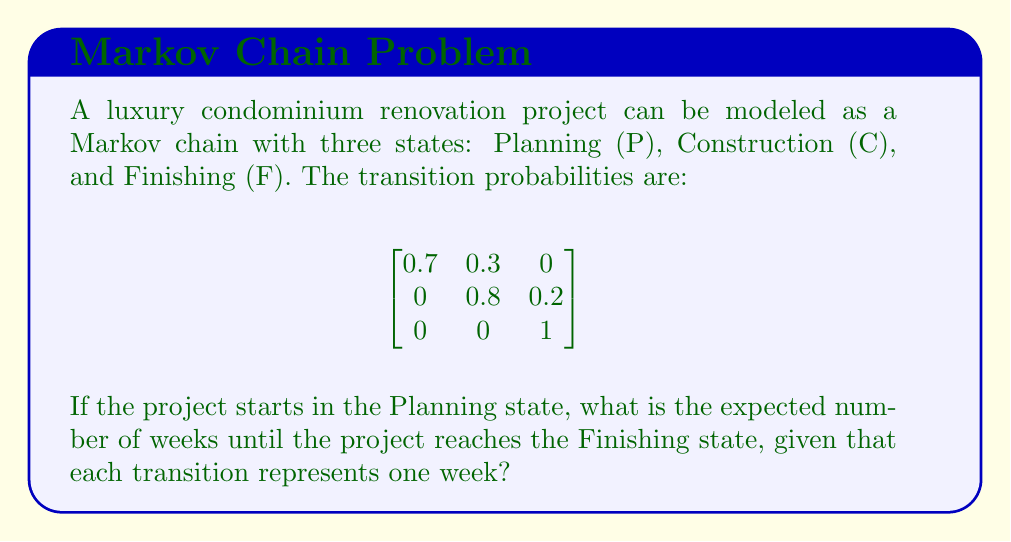Can you solve this math problem? To solve this problem, we'll use the concept of absorption time in Markov chains.

Step 1: Identify the transient states (P and C) and the absorbing state (F).

Step 2: Create the transition matrix Q for the transient states:

$$Q = \begin{bmatrix}
0.7 & 0.3 \\
0 & 0.8
\end{bmatrix}$$

Step 3: Calculate the fundamental matrix N:
$$N = (I - Q)^{-1}$$

Where I is the identity matrix:

$$I - Q = \begin{bmatrix}
1 & 0 \\
0 & 1
\end{bmatrix} - \begin{bmatrix}
0.7 & 0.3 \\
0 & 0.8
\end{bmatrix} = \begin{bmatrix}
0.3 & -0.3 \\
0 & 0.2
\end{bmatrix}$$

$$(I - Q)^{-1} = \frac{1}{0.3 \times 0.2} \begin{bmatrix}
0.2 & 0.3 \\
0 & 0.3
\end{bmatrix} = \begin{bmatrix}
3.33 & 5 \\
0 & 5
\end{bmatrix}$$

Step 4: Calculate the expected number of weeks until absorption (reaching the Finishing state):

The expected number of weeks is the sum of the first row of N (since we start in the Planning state):

$$3.33 + 5 = 8.33$$

Therefore, the expected number of weeks until the project reaches the Finishing state is 8.33 weeks.
Answer: 8.33 weeks 